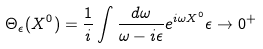<formula> <loc_0><loc_0><loc_500><loc_500>\Theta _ { \epsilon } ( X ^ { 0 } ) = \frac { 1 } { i } \int \frac { d \omega } { \omega - i \epsilon } e ^ { i \omega X ^ { 0 } } \epsilon \to 0 ^ { + }</formula> 